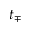<formula> <loc_0><loc_0><loc_500><loc_500>t _ { \mp }</formula> 